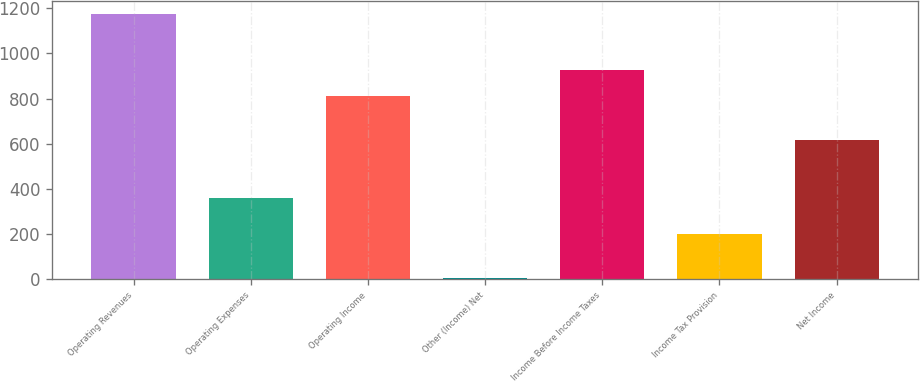<chart> <loc_0><loc_0><loc_500><loc_500><bar_chart><fcel>Operating Revenues<fcel>Operating Expenses<fcel>Operating Income<fcel>Other (Income) Net<fcel>Income Before Income Taxes<fcel>Income Tax Provision<fcel>Net Income<nl><fcel>1173<fcel>361<fcel>812<fcel>5<fcel>928.8<fcel>200<fcel>617<nl></chart> 